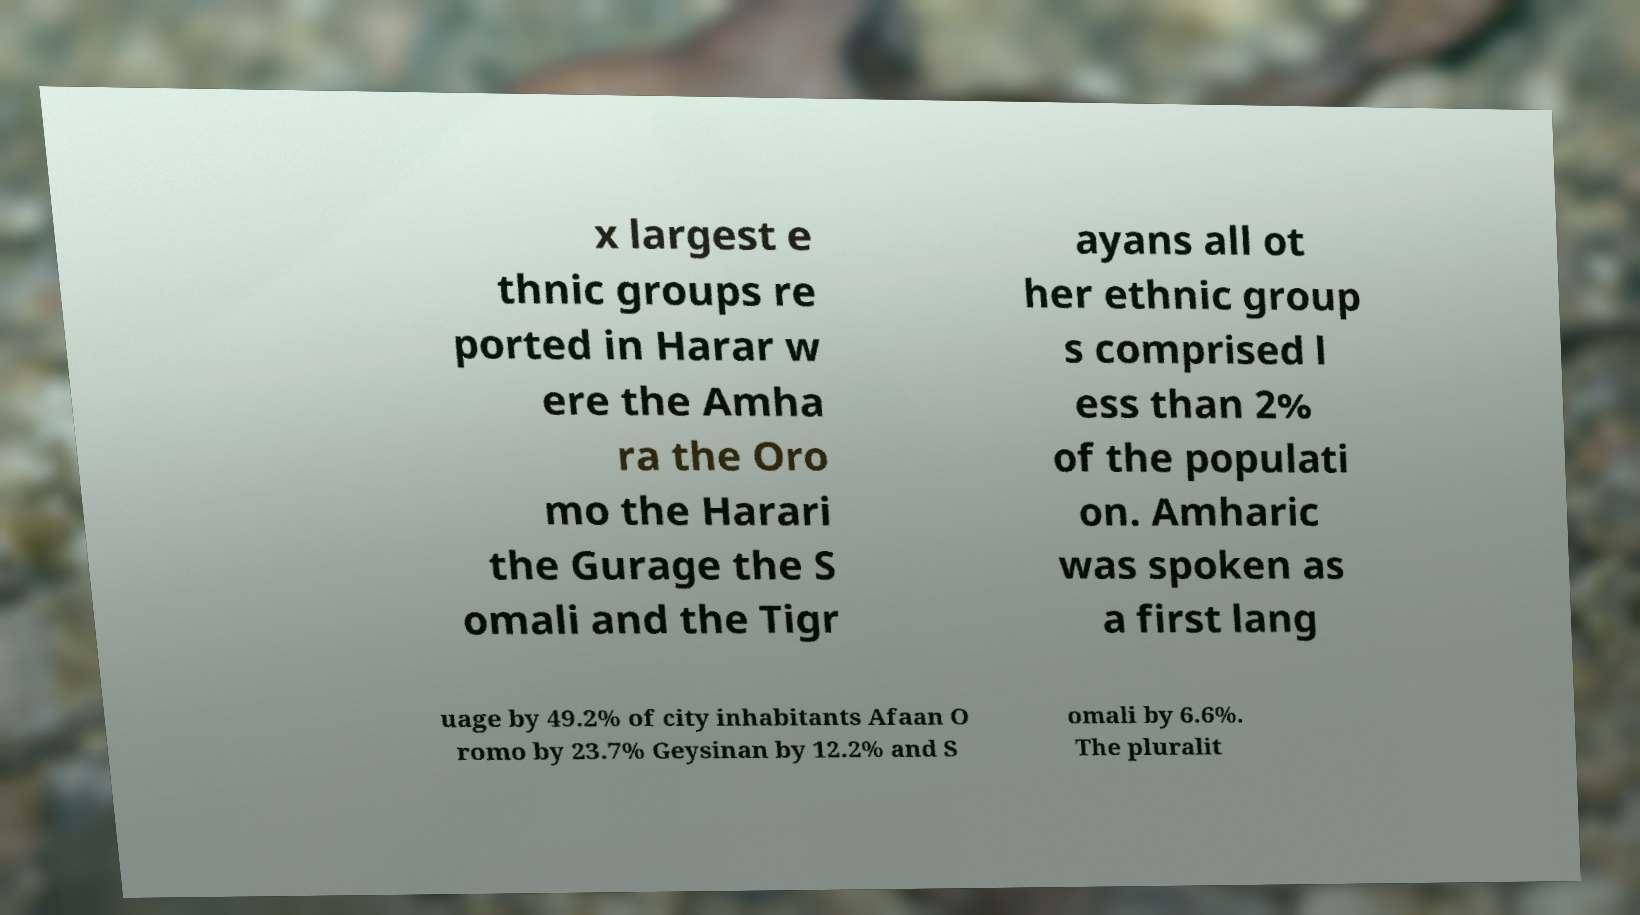Could you extract and type out the text from this image? x largest e thnic groups re ported in Harar w ere the Amha ra the Oro mo the Harari the Gurage the S omali and the Tigr ayans all ot her ethnic group s comprised l ess than 2% of the populati on. Amharic was spoken as a first lang uage by 49.2% of city inhabitants Afaan O romo by 23.7% Geysinan by 12.2% and S omali by 6.6%. The pluralit 